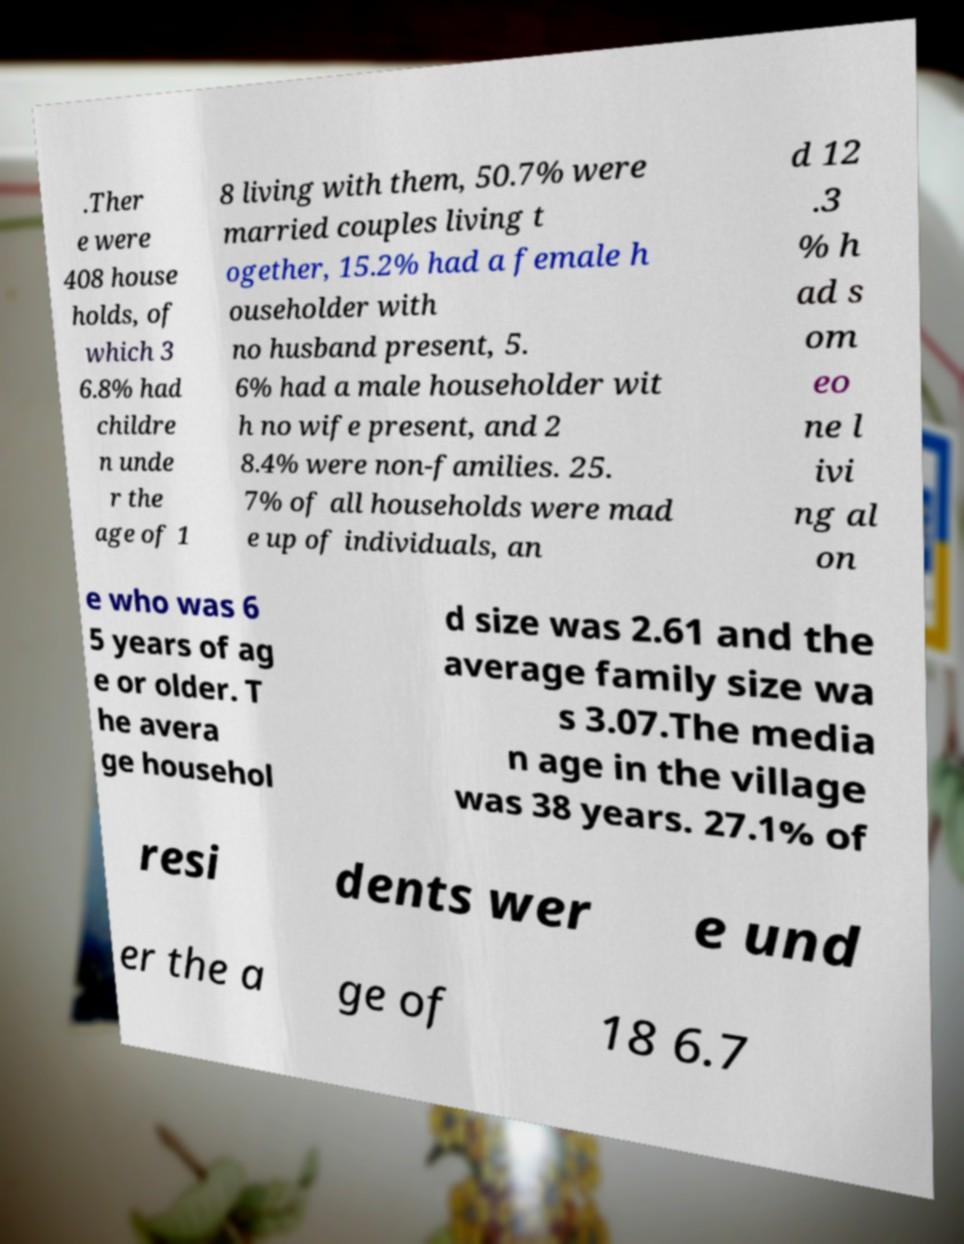What messages or text are displayed in this image? I need them in a readable, typed format. .Ther e were 408 house holds, of which 3 6.8% had childre n unde r the age of 1 8 living with them, 50.7% were married couples living t ogether, 15.2% had a female h ouseholder with no husband present, 5. 6% had a male householder wit h no wife present, and 2 8.4% were non-families. 25. 7% of all households were mad e up of individuals, an d 12 .3 % h ad s om eo ne l ivi ng al on e who was 6 5 years of ag e or older. T he avera ge househol d size was 2.61 and the average family size wa s 3.07.The media n age in the village was 38 years. 27.1% of resi dents wer e und er the a ge of 18 6.7 